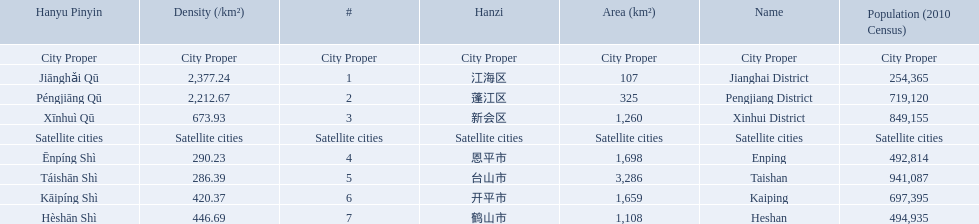What are all the cities? Jianghai District, Pengjiang District, Xinhui District, Enping, Taishan, Kaiping, Heshan. Of these, which are satellite cities? Enping, Taishan, Kaiping, Heshan. For these, what are their populations? 492,814, 941,087, 697,395, 494,935. Of these, which is the largest? 941,087. Which city has this population? Taishan. What city propers are listed? Jianghai District, Pengjiang District, Xinhui District. Which hast he smallest area in km2? Jianghai District. 